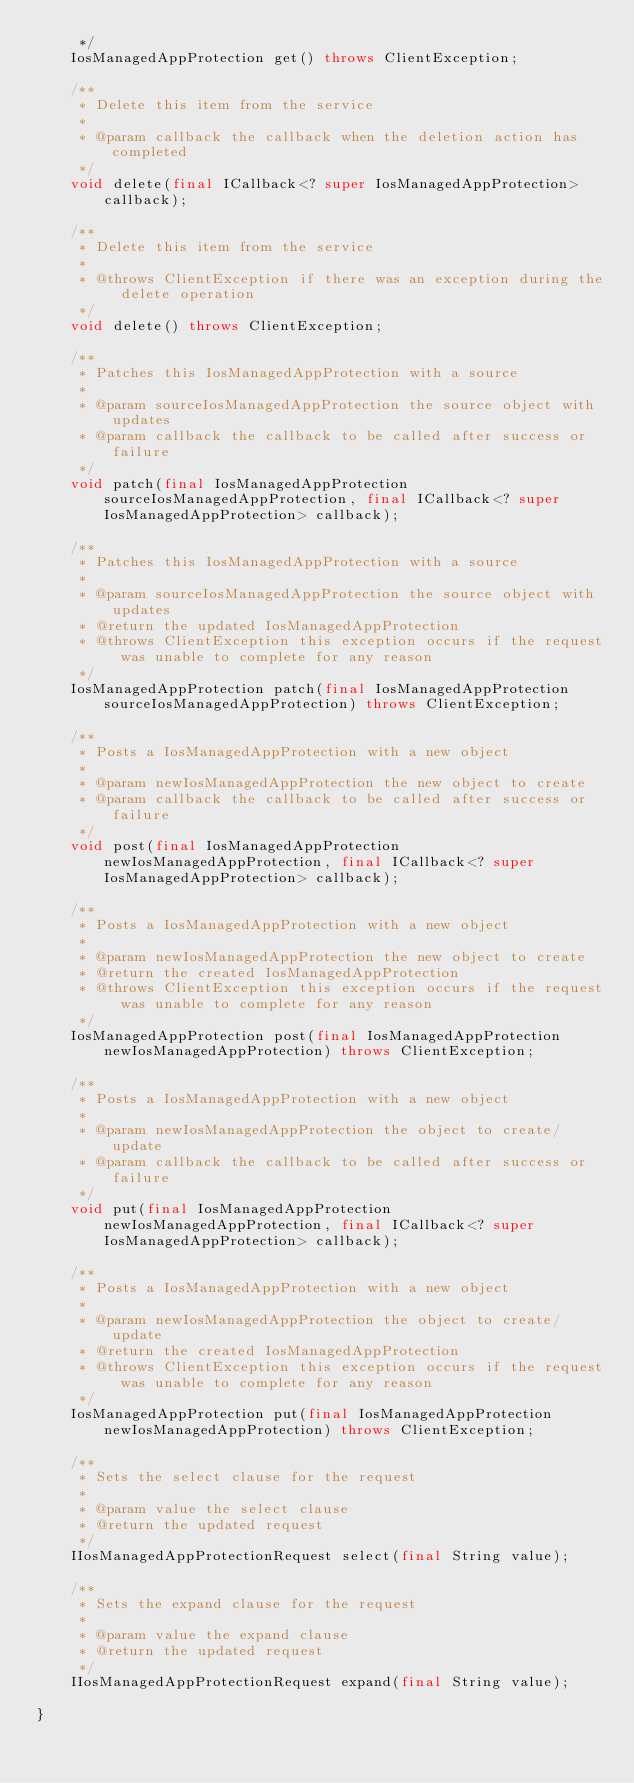Convert code to text. <code><loc_0><loc_0><loc_500><loc_500><_Java_>     */
    IosManagedAppProtection get() throws ClientException;

    /**
     * Delete this item from the service
     *
     * @param callback the callback when the deletion action has completed
     */
    void delete(final ICallback<? super IosManagedAppProtection> callback);

    /**
     * Delete this item from the service
     *
     * @throws ClientException if there was an exception during the delete operation
     */
    void delete() throws ClientException;

    /**
     * Patches this IosManagedAppProtection with a source
     *
     * @param sourceIosManagedAppProtection the source object with updates
     * @param callback the callback to be called after success or failure
     */
    void patch(final IosManagedAppProtection sourceIosManagedAppProtection, final ICallback<? super IosManagedAppProtection> callback);

    /**
     * Patches this IosManagedAppProtection with a source
     *
     * @param sourceIosManagedAppProtection the source object with updates
     * @return the updated IosManagedAppProtection
     * @throws ClientException this exception occurs if the request was unable to complete for any reason
     */
    IosManagedAppProtection patch(final IosManagedAppProtection sourceIosManagedAppProtection) throws ClientException;

    /**
     * Posts a IosManagedAppProtection with a new object
     *
     * @param newIosManagedAppProtection the new object to create
     * @param callback the callback to be called after success or failure
     */
    void post(final IosManagedAppProtection newIosManagedAppProtection, final ICallback<? super IosManagedAppProtection> callback);

    /**
     * Posts a IosManagedAppProtection with a new object
     *
     * @param newIosManagedAppProtection the new object to create
     * @return the created IosManagedAppProtection
     * @throws ClientException this exception occurs if the request was unable to complete for any reason
     */
    IosManagedAppProtection post(final IosManagedAppProtection newIosManagedAppProtection) throws ClientException;

    /**
     * Posts a IosManagedAppProtection with a new object
     *
     * @param newIosManagedAppProtection the object to create/update
     * @param callback the callback to be called after success or failure
     */
    void put(final IosManagedAppProtection newIosManagedAppProtection, final ICallback<? super IosManagedAppProtection> callback);

    /**
     * Posts a IosManagedAppProtection with a new object
     *
     * @param newIosManagedAppProtection the object to create/update
     * @return the created IosManagedAppProtection
     * @throws ClientException this exception occurs if the request was unable to complete for any reason
     */
    IosManagedAppProtection put(final IosManagedAppProtection newIosManagedAppProtection) throws ClientException;

    /**
     * Sets the select clause for the request
     *
     * @param value the select clause
     * @return the updated request
     */
    IIosManagedAppProtectionRequest select(final String value);

    /**
     * Sets the expand clause for the request
     *
     * @param value the expand clause
     * @return the updated request
     */
    IIosManagedAppProtectionRequest expand(final String value);

}

</code> 